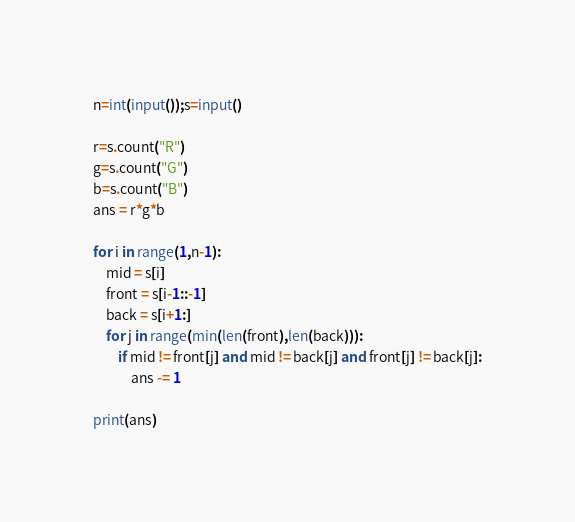<code> <loc_0><loc_0><loc_500><loc_500><_Python_>n=int(input());s=input()

r=s.count("R")
g=s.count("G")
b=s.count("B")
ans = r*g*b

for i in range(1,n-1):
    mid = s[i]
    front = s[i-1::-1]
    back = s[i+1:]
    for j in range(min(len(front),len(back))):
        if mid != front[j] and mid != back[j] and front[j] != back[j]:
            ans -= 1
    
print(ans)
</code> 